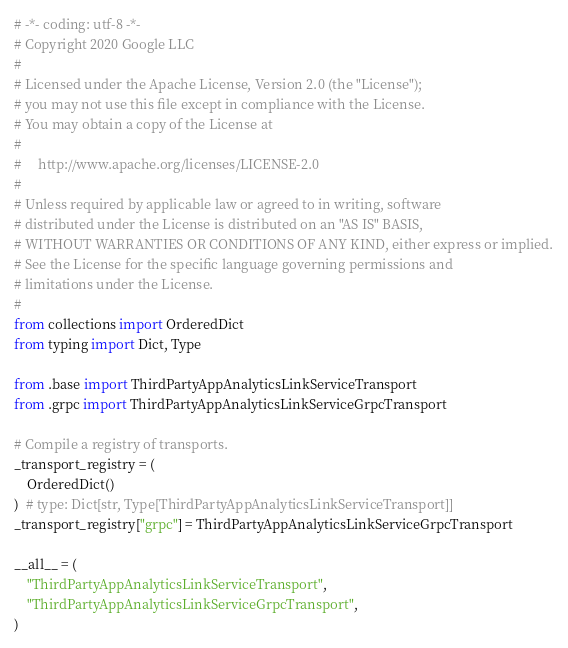Convert code to text. <code><loc_0><loc_0><loc_500><loc_500><_Python_># -*- coding: utf-8 -*-
# Copyright 2020 Google LLC
#
# Licensed under the Apache License, Version 2.0 (the "License");
# you may not use this file except in compliance with the License.
# You may obtain a copy of the License at
#
#     http://www.apache.org/licenses/LICENSE-2.0
#
# Unless required by applicable law or agreed to in writing, software
# distributed under the License is distributed on an "AS IS" BASIS,
# WITHOUT WARRANTIES OR CONDITIONS OF ANY KIND, either express or implied.
# See the License for the specific language governing permissions and
# limitations under the License.
#
from collections import OrderedDict
from typing import Dict, Type

from .base import ThirdPartyAppAnalyticsLinkServiceTransport
from .grpc import ThirdPartyAppAnalyticsLinkServiceGrpcTransport

# Compile a registry of transports.
_transport_registry = (
    OrderedDict()
)  # type: Dict[str, Type[ThirdPartyAppAnalyticsLinkServiceTransport]]
_transport_registry["grpc"] = ThirdPartyAppAnalyticsLinkServiceGrpcTransport

__all__ = (
    "ThirdPartyAppAnalyticsLinkServiceTransport",
    "ThirdPartyAppAnalyticsLinkServiceGrpcTransport",
)
</code> 